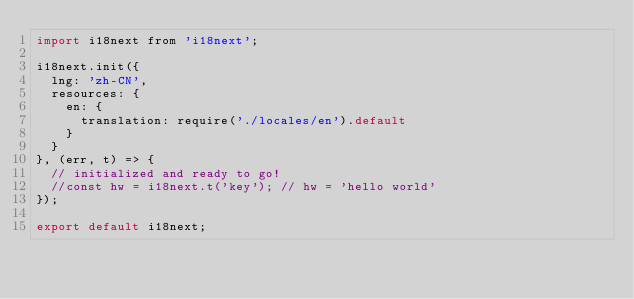Convert code to text. <code><loc_0><loc_0><loc_500><loc_500><_JavaScript_>import i18next from 'i18next';

i18next.init({
  lng: 'zh-CN',
  resources: {
    en: {
      translation: require('./locales/en').default
    }
  }
}, (err, t) => {
  // initialized and ready to go!
  //const hw = i18next.t('key'); // hw = 'hello world'
});

export default i18next;
</code> 